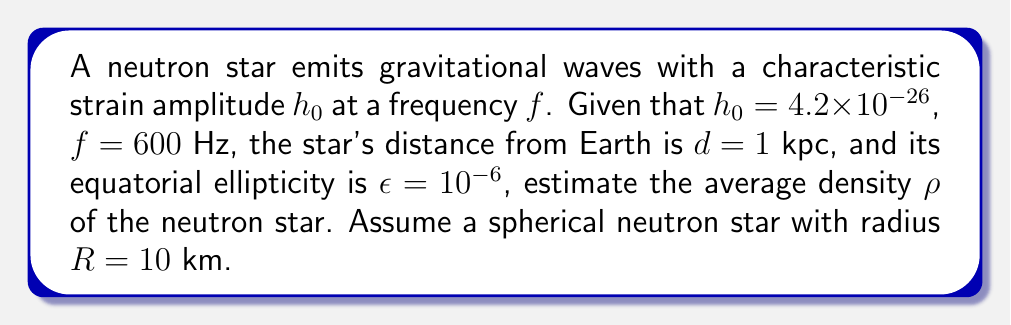Provide a solution to this math problem. To estimate the average density of the neutron star, we'll follow these steps:

1) The characteristic strain amplitude $h_0$ for a rotating neutron star is given by:

   $$h_0 = \frac{4\pi^2 G}{c^4} \frac{I_{zz} \epsilon f^2}{d}$$

   where $G$ is the gravitational constant, $c$ is the speed of light, $I_{zz}$ is the moment of inertia about the rotation axis, and $\epsilon$ is the equatorial ellipticity.

2) We can rearrange this equation to solve for $I_{zz}$:

   $$I_{zz} = \frac{h_0 c^4 d}{4\pi^2 G \epsilon f^2}$$

3) For a sphere, the moment of inertia is given by:

   $$I_{zz} = \frac{2}{5} M R^2$$

   where $M$ is the mass and $R$ is the radius.

4) The mass can be expressed in terms of density and volume:

   $$M = \rho V = \rho \frac{4}{3} \pi R^3$$

5) Substituting this into the moment of inertia equation:

   $$I_{zz} = \frac{2}{5} \rho \frac{4}{3} \pi R^5$$

6) Now we can equate the two expressions for $I_{zz}$ and solve for $\rho$:

   $$\frac{h_0 c^4 d}{4\pi^2 G \epsilon f^2} = \frac{2}{5} \rho \frac{4}{3} \pi R^5$$

   $$\rho = \frac{15 h_0 c^4 d}{32\pi^3 G \epsilon f^2 R^5}$$

7) Now we can substitute the given values:
   $h_0 = 4.2 \times 10^{-26}$
   $c = 3 \times 10^8$ m/s
   $d = 1$ kpc $= 3.086 \times 10^{19}$ m
   $G = 6.674 \times 10^{-11}$ N⋅m²/kg²
   $\epsilon = 10^{-6}$
   $f = 600$ Hz
   $R = 10$ km $= 10^4$ m

8) Calculating:

   $$\rho = \frac{15 (4.2 \times 10^{-26}) (3 \times 10^8)^4 (3.086 \times 10^{19})}{32\pi^3 (6.674 \times 10^{-11}) (10^{-6}) (600)^2 (10^4)^5}$$

   $$\rho \approx 7.8 \times 10^{17} \text{ kg/m³}$$
Answer: $7.8 \times 10^{17}$ kg/m³ 